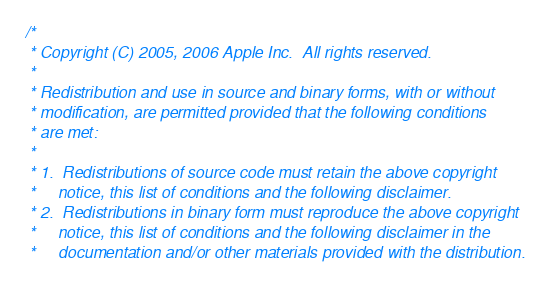Convert code to text. <code><loc_0><loc_0><loc_500><loc_500><_ObjectiveC_>/*
 * Copyright (C) 2005, 2006 Apple Inc.  All rights reserved.
 *
 * Redistribution and use in source and binary forms, with or without
 * modification, are permitted provided that the following conditions
 * are met:
 *
 * 1.  Redistributions of source code must retain the above copyright
 *     notice, this list of conditions and the following disclaimer. 
 * 2.  Redistributions in binary form must reproduce the above copyright
 *     notice, this list of conditions and the following disclaimer in the
 *     documentation and/or other materials provided with the distribution. </code> 